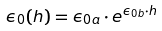<formula> <loc_0><loc_0><loc_500><loc_500>\epsilon _ { 0 } ( h ) = \epsilon _ { 0 a } \cdot e ^ { \epsilon _ { 0 b } \cdot h }</formula> 